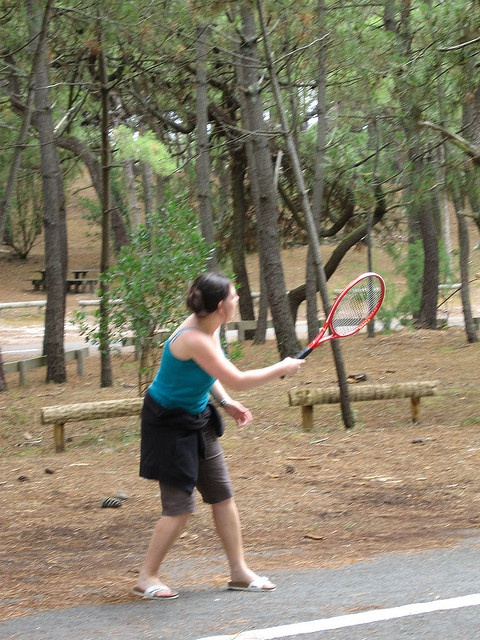Describe the objects in this image and their specific colors. I can see people in olive, black, gray, white, and blue tones, tennis racket in olive, darkgray, lightgray, tan, and lightpink tones, bench in olive, tan, and gray tones, bench in olive, gray, and black tones, and bench in olive, black, and gray tones in this image. 